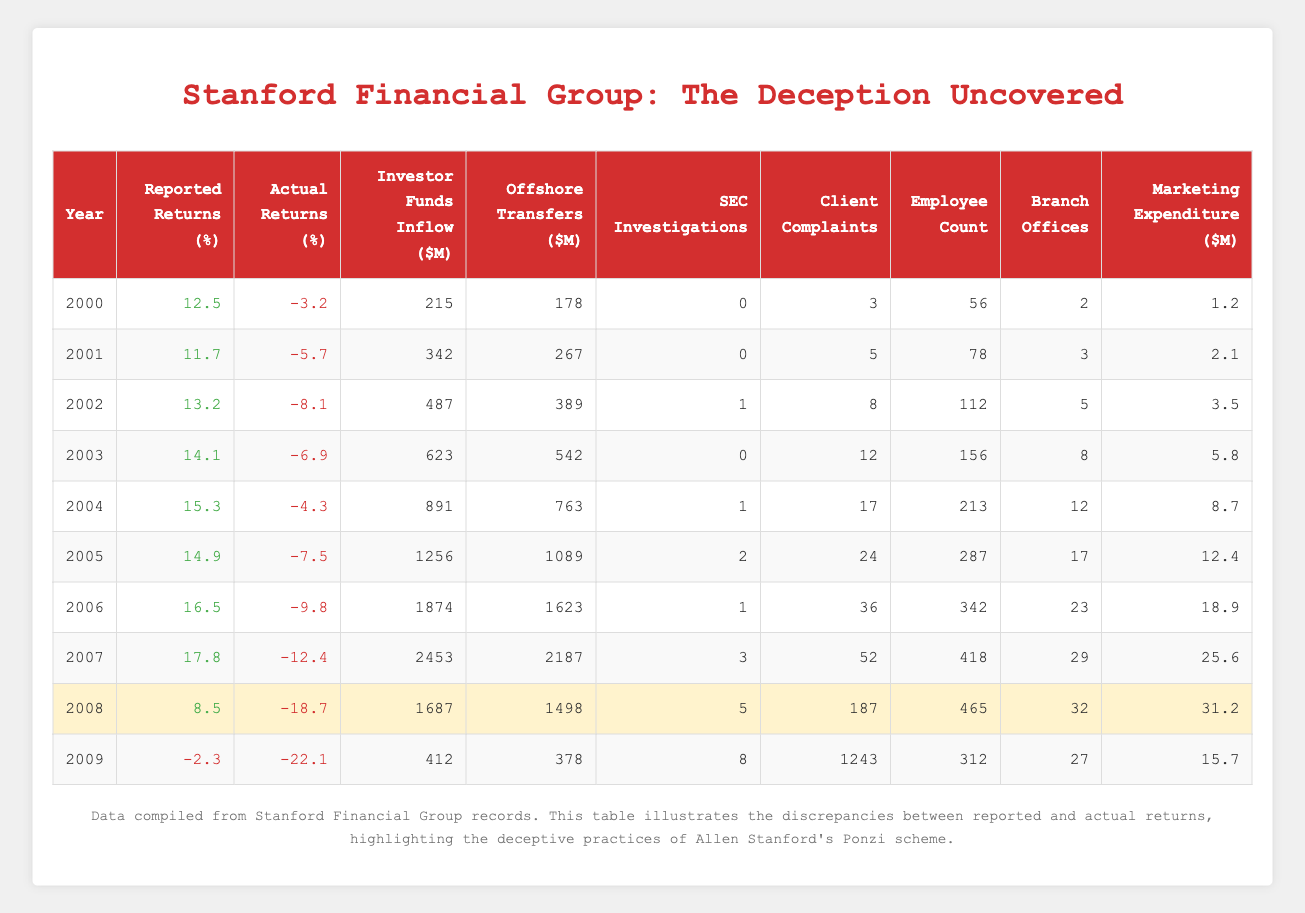What were the reported returns for the year 2006? Looking at the row for the year 2006, the reported returns are listed as 16.5%.
Answer: 16.5% Which year had the highest actual returns? Reviewing the actual returns across all years, the year with the highest actual return is 2000 with -3.2%.
Answer: 2000 What is the average reported returns from 2004 to 2008? The reported returns from 2004 to 2008 are 15.3%, 14.9%, 16.5%, 17.8%, and 8.5%. Summing these gives us 72.0%, and dividing by 5 years gives an average of 14.4%.
Answer: 14.4% Did the number of SEC investigations increase every year? By analyzing the SEC investigations column, we can see that there are fluctuations in SEC investigations: 0 in 2000, 0 in 2001, 1 in 2002, 0 in 2003, 1 in 2004, 2 in 2005, 1 in 2006, 3 in 2007, 5 in 2008, and 8 in 2009. Hence, the number did not increase every year.
Answer: No What was the total investor funds inflow from 2000 to 2005? The investor funds inflow from 2000 to 2005 is 215, 342, 487, 623, 891, and 1256. Adding these yields: 215 + 342 + 487 + 623 + 891 + 1256 = 2814.
Answer: 2814 How many client complaints were there in total over the years listed? The total client complaints from 2000 to 2009 are 3, 5, 8, 12, 17, 24, 36, 52, 187, and 1243. Adding these values gives a total of 1537 complaints.
Answer: 1537 In which year did employee count first exceed 200? Observing the employee count data, the first year exceeding 200 employees is 2004, where the count reaches 213.
Answer: 2004 What was the difference between reported and actual returns in 2008? In 2008, the reported return is 8.5% and the actual return is -18.7%. The difference is calculated as 8.5 - (-18.7) = 8.5 + 18.7 = 27.2%.
Answer: 27.2% Which year had the highest marketing expenditure? Reviewing the marketing expenditure values, 2007 has the highest spending at 25.6 million dollars.
Answer: 2007 